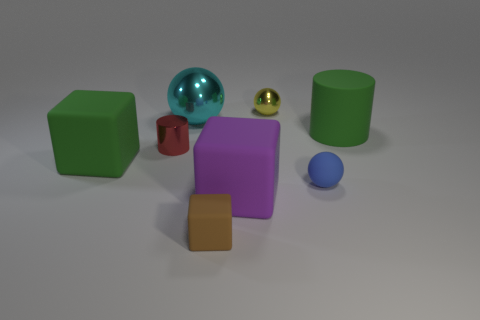Is there anything else that is the same shape as the tiny yellow thing?
Provide a short and direct response. Yes. The cyan metallic object that is the same shape as the yellow object is what size?
Ensure brevity in your answer.  Large. Is the shape of the blue matte thing the same as the tiny yellow object?
Offer a very short reply. Yes. There is a large object in front of the big green thing that is left of the large green matte cylinder; what is it made of?
Your answer should be compact. Rubber. Is the number of cylinders that are to the left of the green rubber block less than the number of green cubes?
Your answer should be very brief. Yes. What shape is the green rubber object that is on the left side of the tiny matte cube?
Your answer should be compact. Cube. Does the purple matte object have the same size as the sphere on the left side of the big purple object?
Keep it short and to the point. Yes. Are there any red cylinders that have the same material as the tiny cube?
Ensure brevity in your answer.  No. How many cubes are either tiny blue things or cyan shiny things?
Offer a terse response. 0. Are there any cyan metal balls that are in front of the big green rubber cylinder that is behind the brown object?
Provide a short and direct response. No. 